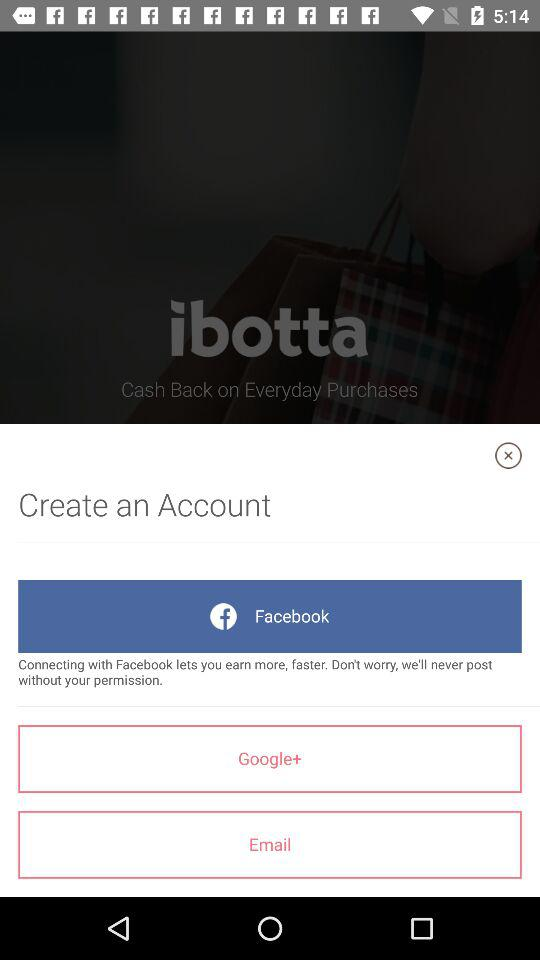Which application can we use to create an account? You can use "Facebook" and "Google+" to create an account. 